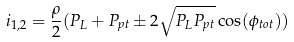<formula> <loc_0><loc_0><loc_500><loc_500>i _ { 1 , 2 } = \frac { \rho } { 2 } ( P _ { L } + P _ { p t } \pm 2 \sqrt { P _ { L } P _ { p t } } \cos ( \phi _ { t o t } ) )</formula> 